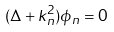Convert formula to latex. <formula><loc_0><loc_0><loc_500><loc_500>( \Delta + k ^ { 2 } _ { n } ) \phi _ { n } = 0</formula> 